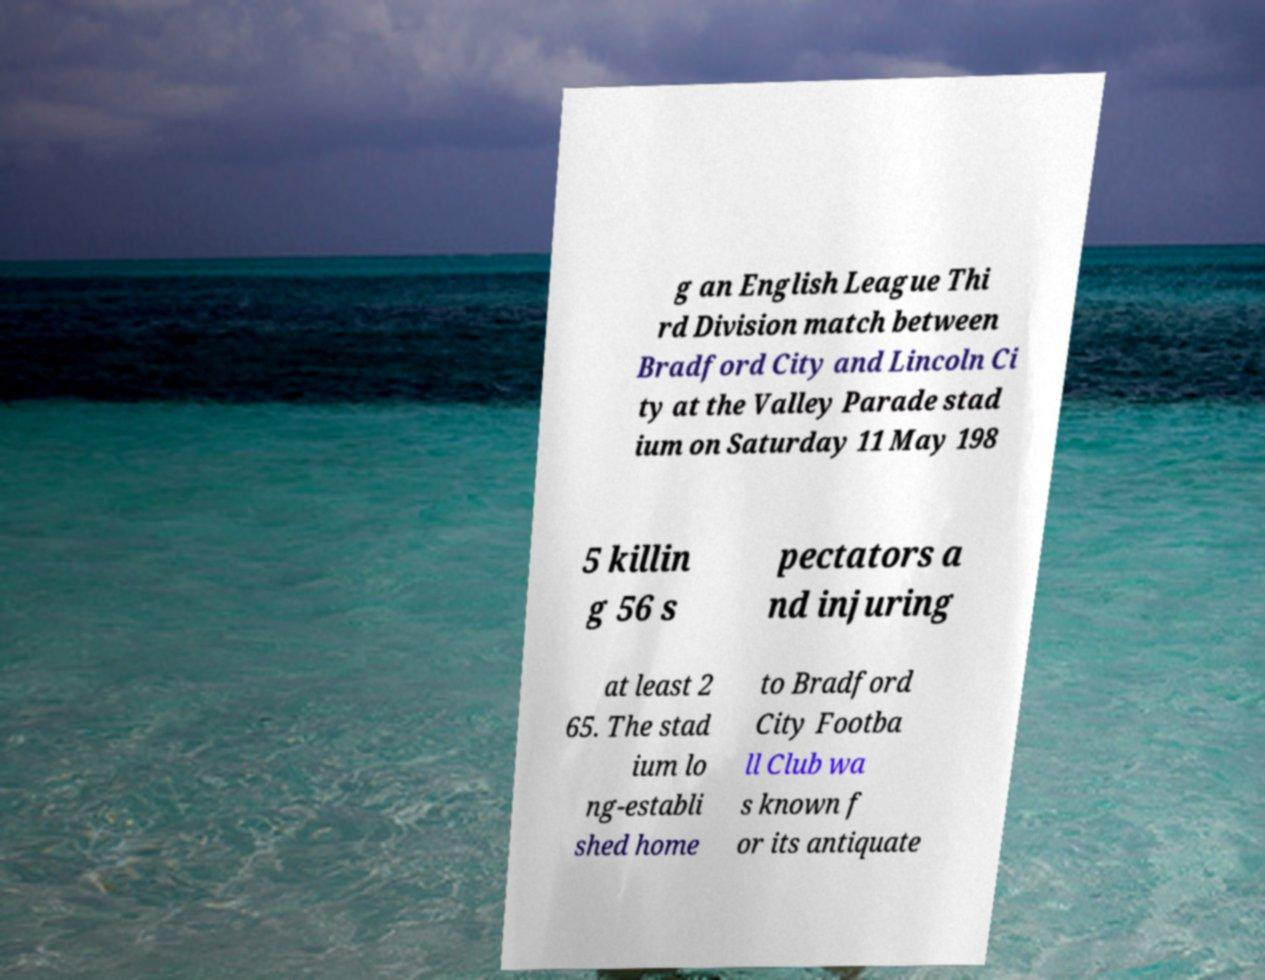Could you assist in decoding the text presented in this image and type it out clearly? g an English League Thi rd Division match between Bradford City and Lincoln Ci ty at the Valley Parade stad ium on Saturday 11 May 198 5 killin g 56 s pectators a nd injuring at least 2 65. The stad ium lo ng-establi shed home to Bradford City Footba ll Club wa s known f or its antiquate 